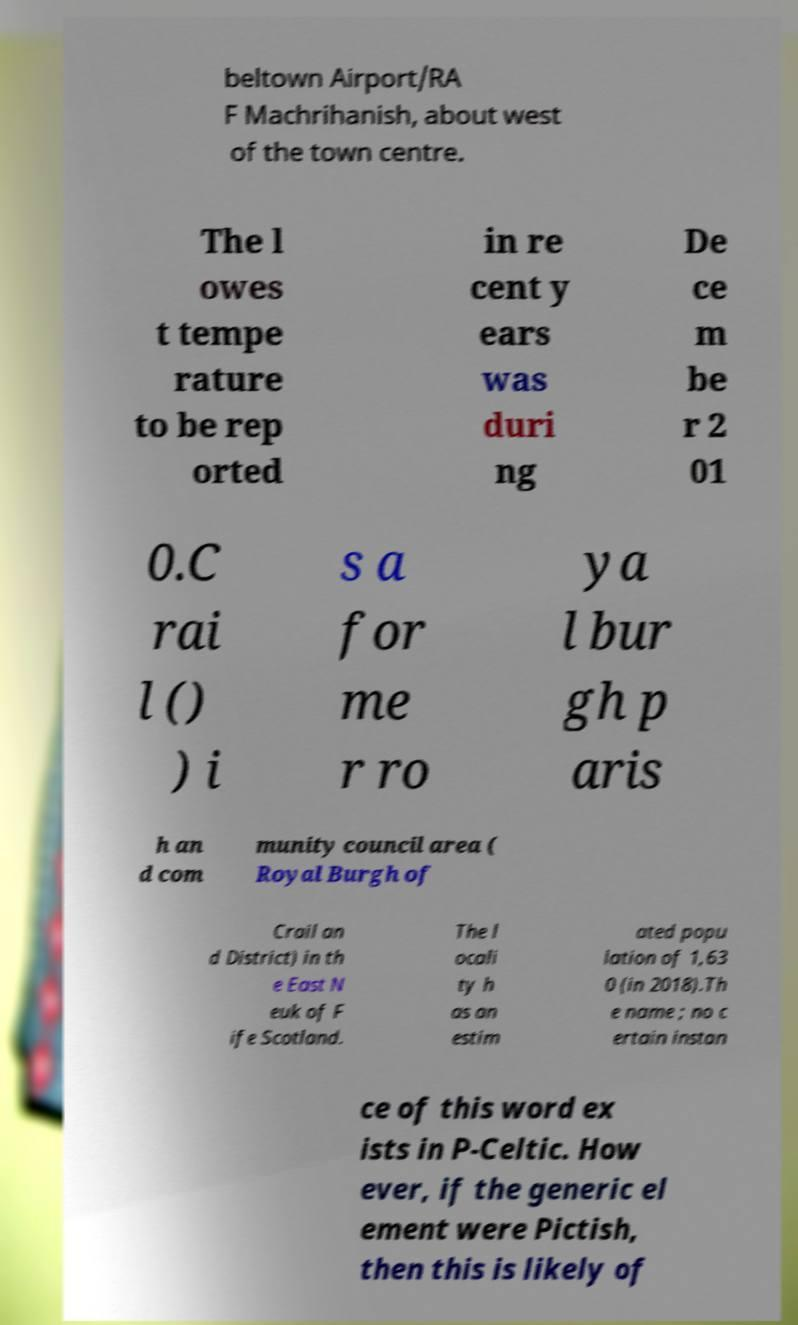For documentation purposes, I need the text within this image transcribed. Could you provide that? beltown Airport/RA F Machrihanish, about west of the town centre. The l owes t tempe rature to be rep orted in re cent y ears was duri ng De ce m be r 2 01 0.C rai l () ) i s a for me r ro ya l bur gh p aris h an d com munity council area ( Royal Burgh of Crail an d District) in th e East N euk of F ife Scotland. The l ocali ty h as an estim ated popu lation of 1,63 0 (in 2018).Th e name ; no c ertain instan ce of this word ex ists in P-Celtic. How ever, if the generic el ement were Pictish, then this is likely of 